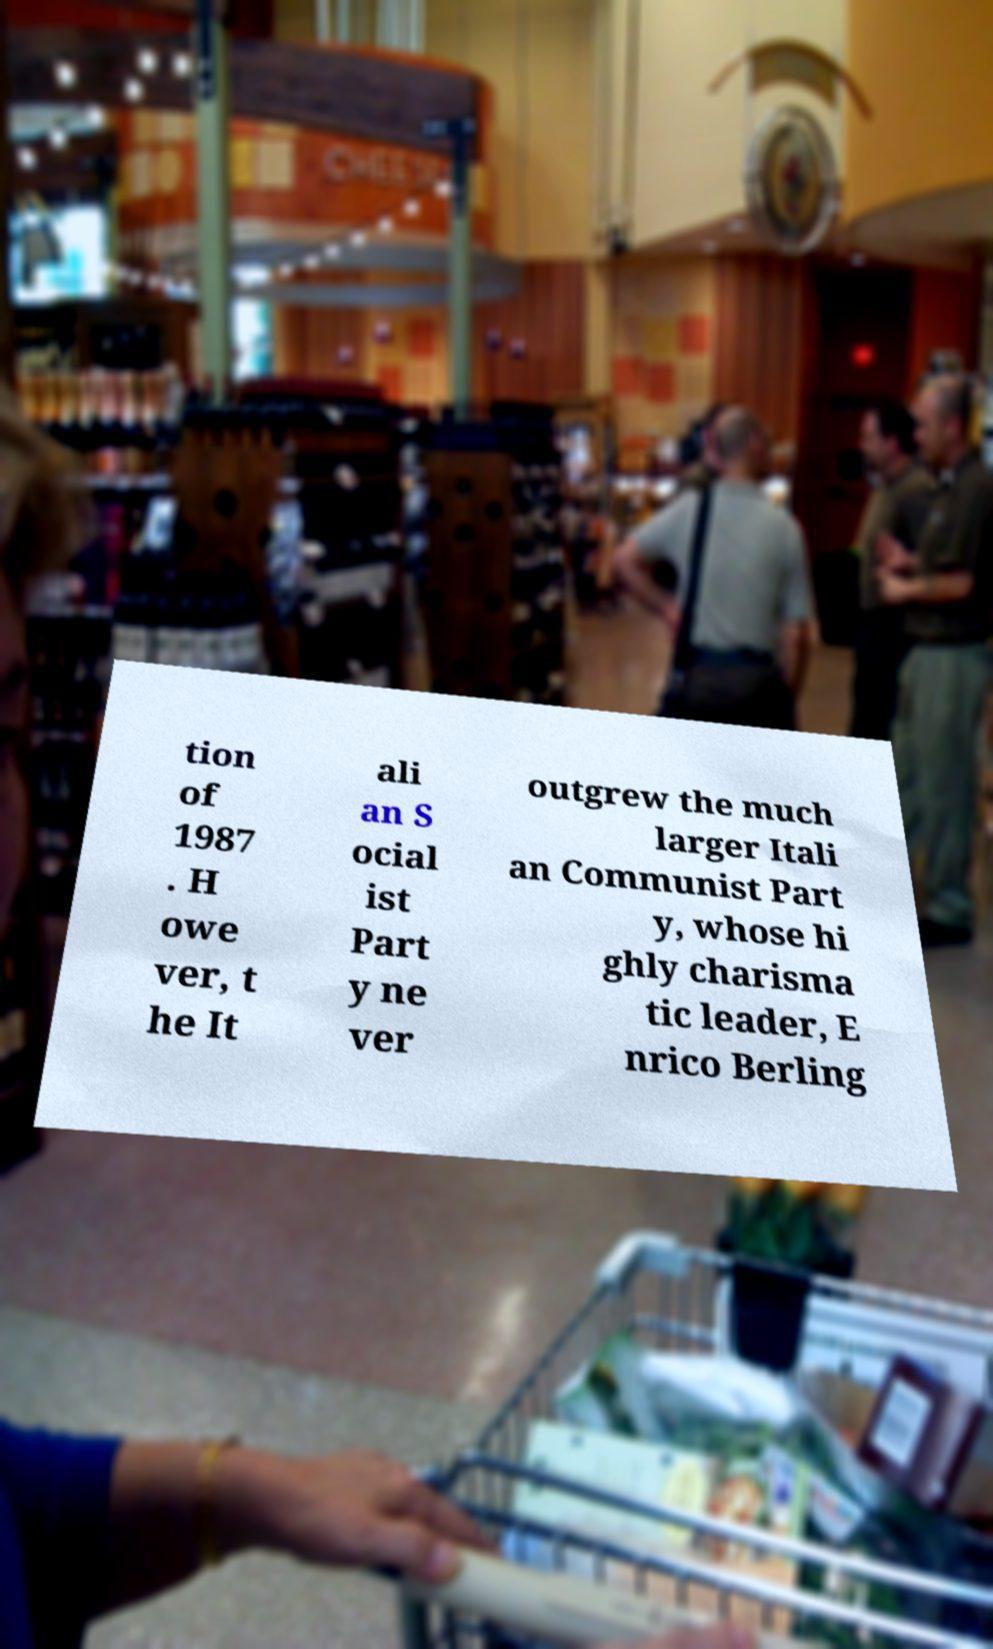Can you read and provide the text displayed in the image?This photo seems to have some interesting text. Can you extract and type it out for me? tion of 1987 . H owe ver, t he It ali an S ocial ist Part y ne ver outgrew the much larger Itali an Communist Part y, whose hi ghly charisma tic leader, E nrico Berling 